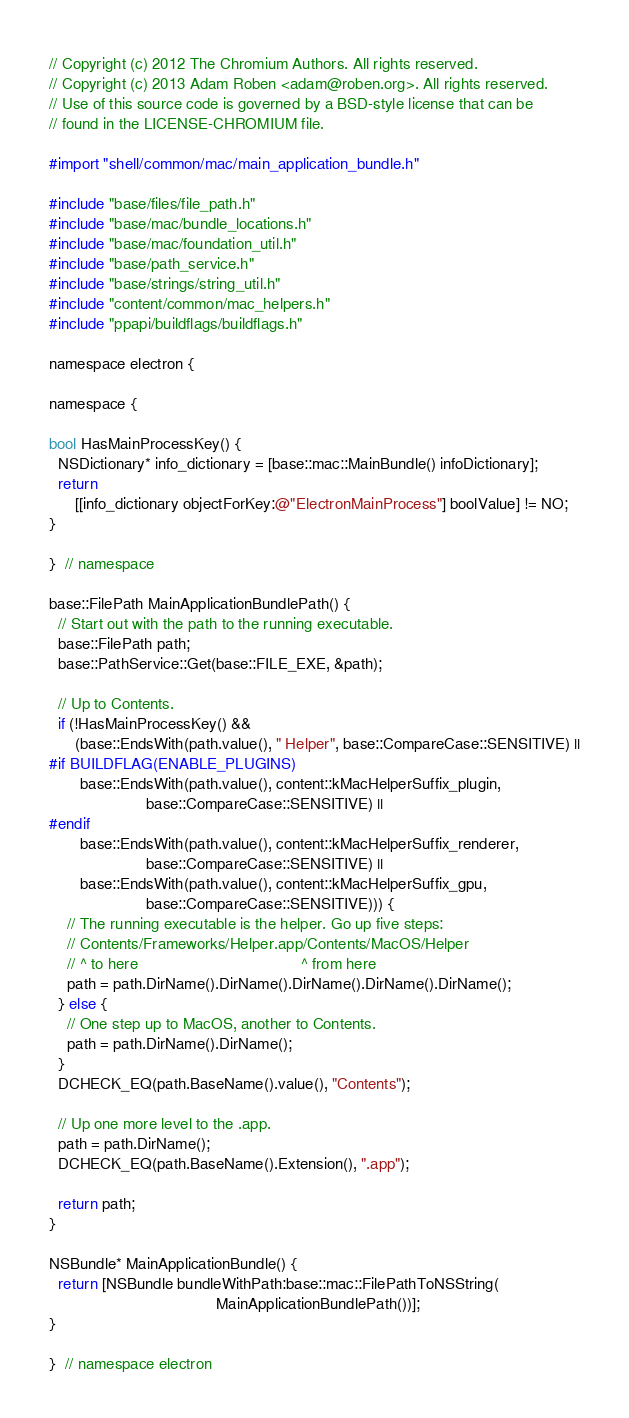<code> <loc_0><loc_0><loc_500><loc_500><_ObjectiveC_>// Copyright (c) 2012 The Chromium Authors. All rights reserved.
// Copyright (c) 2013 Adam Roben <adam@roben.org>. All rights reserved.
// Use of this source code is governed by a BSD-style license that can be
// found in the LICENSE-CHROMIUM file.

#import "shell/common/mac/main_application_bundle.h"

#include "base/files/file_path.h"
#include "base/mac/bundle_locations.h"
#include "base/mac/foundation_util.h"
#include "base/path_service.h"
#include "base/strings/string_util.h"
#include "content/common/mac_helpers.h"
#include "ppapi/buildflags/buildflags.h"

namespace electron {

namespace {

bool HasMainProcessKey() {
  NSDictionary* info_dictionary = [base::mac::MainBundle() infoDictionary];
  return
      [[info_dictionary objectForKey:@"ElectronMainProcess"] boolValue] != NO;
}

}  // namespace

base::FilePath MainApplicationBundlePath() {
  // Start out with the path to the running executable.
  base::FilePath path;
  base::PathService::Get(base::FILE_EXE, &path);

  // Up to Contents.
  if (!HasMainProcessKey() &&
      (base::EndsWith(path.value(), " Helper", base::CompareCase::SENSITIVE) ||
#if BUILDFLAG(ENABLE_PLUGINS)
       base::EndsWith(path.value(), content::kMacHelperSuffix_plugin,
                      base::CompareCase::SENSITIVE) ||
#endif
       base::EndsWith(path.value(), content::kMacHelperSuffix_renderer,
                      base::CompareCase::SENSITIVE) ||
       base::EndsWith(path.value(), content::kMacHelperSuffix_gpu,
                      base::CompareCase::SENSITIVE))) {
    // The running executable is the helper. Go up five steps:
    // Contents/Frameworks/Helper.app/Contents/MacOS/Helper
    // ^ to here                                     ^ from here
    path = path.DirName().DirName().DirName().DirName().DirName();
  } else {
    // One step up to MacOS, another to Contents.
    path = path.DirName().DirName();
  }
  DCHECK_EQ(path.BaseName().value(), "Contents");

  // Up one more level to the .app.
  path = path.DirName();
  DCHECK_EQ(path.BaseName().Extension(), ".app");

  return path;
}

NSBundle* MainApplicationBundle() {
  return [NSBundle bundleWithPath:base::mac::FilePathToNSString(
                                      MainApplicationBundlePath())];
}

}  // namespace electron
</code> 